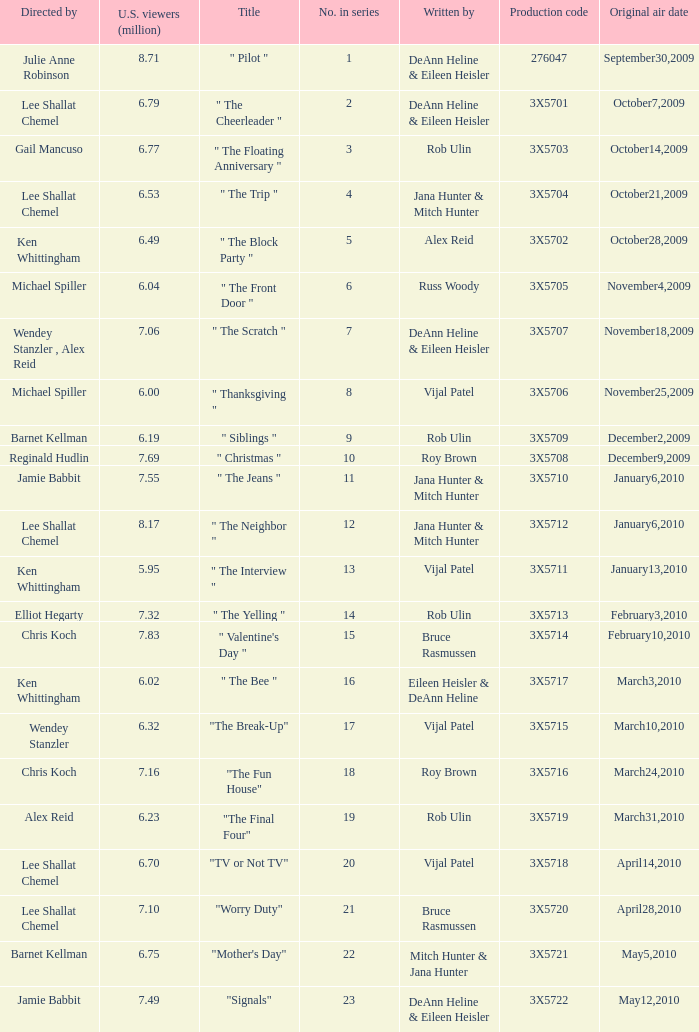Parse the full table. {'header': ['Directed by', 'U.S. viewers (million)', 'Title', 'No. in series', 'Written by', 'Production code', 'Original air date'], 'rows': [['Julie Anne Robinson', '8.71', '" Pilot "', '1', 'DeAnn Heline & Eileen Heisler', '276047', 'September30,2009'], ['Lee Shallat Chemel', '6.79', '" The Cheerleader "', '2', 'DeAnn Heline & Eileen Heisler', '3X5701', 'October7,2009'], ['Gail Mancuso', '6.77', '" The Floating Anniversary "', '3', 'Rob Ulin', '3X5703', 'October14,2009'], ['Lee Shallat Chemel', '6.53', '" The Trip "', '4', 'Jana Hunter & Mitch Hunter', '3X5704', 'October21,2009'], ['Ken Whittingham', '6.49', '" The Block Party "', '5', 'Alex Reid', '3X5702', 'October28,2009'], ['Michael Spiller', '6.04', '" The Front Door "', '6', 'Russ Woody', '3X5705', 'November4,2009'], ['Wendey Stanzler , Alex Reid', '7.06', '" The Scratch "', '7', 'DeAnn Heline & Eileen Heisler', '3X5707', 'November18,2009'], ['Michael Spiller', '6.00', '" Thanksgiving "', '8', 'Vijal Patel', '3X5706', 'November25,2009'], ['Barnet Kellman', '6.19', '" Siblings "', '9', 'Rob Ulin', '3X5709', 'December2,2009'], ['Reginald Hudlin', '7.69', '" Christmas "', '10', 'Roy Brown', '3X5708', 'December9,2009'], ['Jamie Babbit', '7.55', '" The Jeans "', '11', 'Jana Hunter & Mitch Hunter', '3X5710', 'January6,2010'], ['Lee Shallat Chemel', '8.17', '" The Neighbor "', '12', 'Jana Hunter & Mitch Hunter', '3X5712', 'January6,2010'], ['Ken Whittingham', '5.95', '" The Interview "', '13', 'Vijal Patel', '3X5711', 'January13,2010'], ['Elliot Hegarty', '7.32', '" The Yelling "', '14', 'Rob Ulin', '3X5713', 'February3,2010'], ['Chris Koch', '7.83', '" Valentine\'s Day "', '15', 'Bruce Rasmussen', '3X5714', 'February10,2010'], ['Ken Whittingham', '6.02', '" The Bee "', '16', 'Eileen Heisler & DeAnn Heline', '3X5717', 'March3,2010'], ['Wendey Stanzler', '6.32', '"The Break-Up"', '17', 'Vijal Patel', '3X5715', 'March10,2010'], ['Chris Koch', '7.16', '"The Fun House"', '18', 'Roy Brown', '3X5716', 'March24,2010'], ['Alex Reid', '6.23', '"The Final Four"', '19', 'Rob Ulin', '3X5719', 'March31,2010'], ['Lee Shallat Chemel', '6.70', '"TV or Not TV"', '20', 'Vijal Patel', '3X5718', 'April14,2010'], ['Lee Shallat Chemel', '7.10', '"Worry Duty"', '21', 'Bruce Rasmussen', '3X5720', 'April28,2010'], ['Barnet Kellman', '6.75', '"Mother\'s Day"', '22', 'Mitch Hunter & Jana Hunter', '3X5721', 'May5,2010'], ['Jamie Babbit', '7.49', '"Signals"', '23', 'DeAnn Heline & Eileen Heisler', '3X5722', 'May12,2010']]} How many directors got 6.79 million U.S. viewers from their episodes? 1.0. 